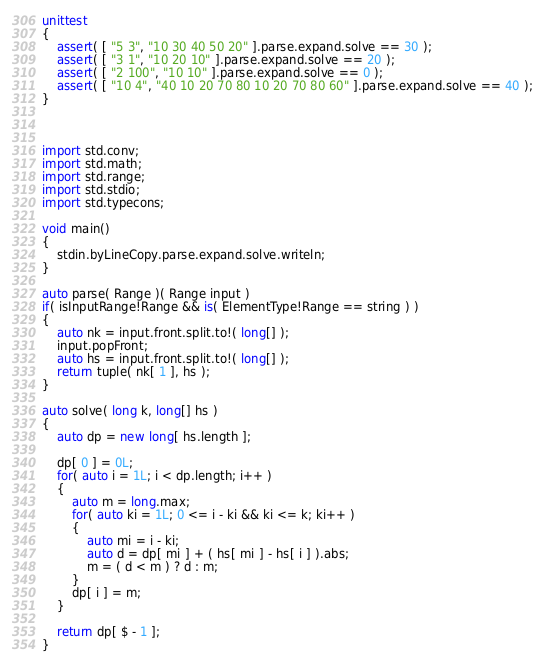Convert code to text. <code><loc_0><loc_0><loc_500><loc_500><_D_>unittest
{
	assert( [ "5 3", "10 30 40 50 20" ].parse.expand.solve == 30 );
	assert( [ "3 1", "10 20 10" ].parse.expand.solve == 20 );
	assert( [ "2 100", "10 10" ].parse.expand.solve == 0 );
	assert( [ "10 4", "40 10 20 70 80 10 20 70 80 60" ].parse.expand.solve == 40 );
}



import std.conv;
import std.math;
import std.range;
import std.stdio;
import std.typecons;

void main()
{
	stdin.byLineCopy.parse.expand.solve.writeln;
}

auto parse( Range )( Range input )
if( isInputRange!Range && is( ElementType!Range == string ) )
{
	auto nk = input.front.split.to!( long[] );
	input.popFront;
	auto hs = input.front.split.to!( long[] );
	return tuple( nk[ 1 ], hs );
}

auto solve( long k, long[] hs )
{
	auto dp = new long[ hs.length ];
	
	dp[ 0 ] = 0L;
	for( auto i = 1L; i < dp.length; i++ )
	{
		auto m = long.max;
		for( auto ki = 1L; 0 <= i - ki && ki <= k; ki++ )
		{
			auto mi = i - ki;
			auto d = dp[ mi ] + ( hs[ mi ] - hs[ i ] ).abs;
			m = ( d < m ) ? d : m;
		}
		dp[ i ] = m;
	}
	
	return dp[ $ - 1 ];
}
</code> 